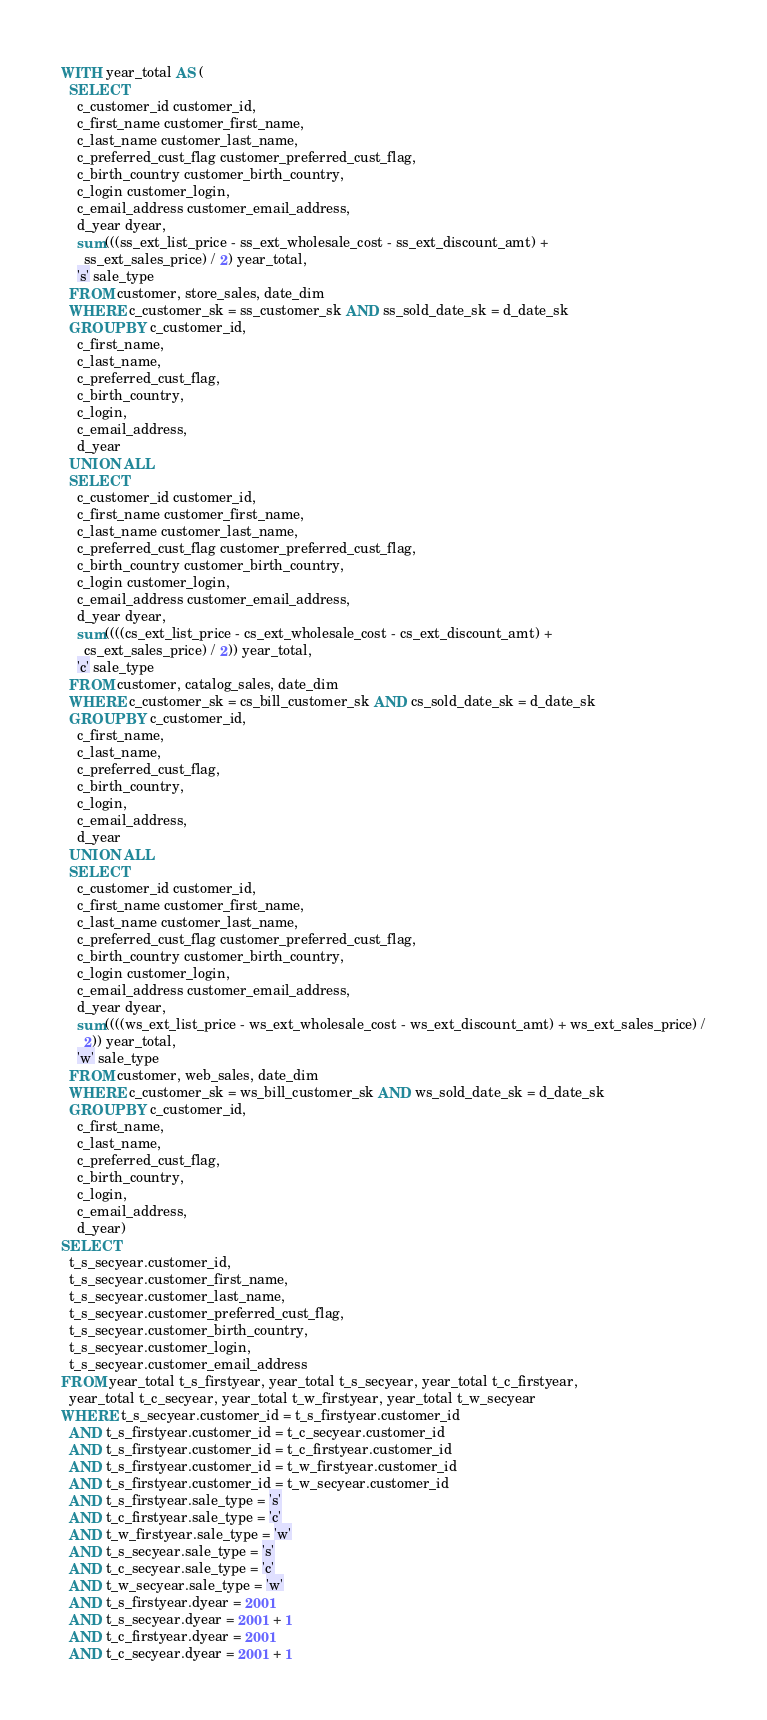<code> <loc_0><loc_0><loc_500><loc_500><_SQL_>WITH year_total AS (
  SELECT
    c_customer_id customer_id,
    c_first_name customer_first_name,
    c_last_name customer_last_name,
    c_preferred_cust_flag customer_preferred_cust_flag,
    c_birth_country customer_birth_country,
    c_login customer_login,
    c_email_address customer_email_address,
    d_year dyear,
    sum(((ss_ext_list_price - ss_ext_wholesale_cost - ss_ext_discount_amt) +
      ss_ext_sales_price) / 2) year_total,
    's' sale_type
  FROM customer, store_sales, date_dim
  WHERE c_customer_sk = ss_customer_sk AND ss_sold_date_sk = d_date_sk
  GROUP BY c_customer_id,
    c_first_name,
    c_last_name,
    c_preferred_cust_flag,
    c_birth_country,
    c_login,
    c_email_address,
    d_year
  UNION ALL
  SELECT
    c_customer_id customer_id,
    c_first_name customer_first_name,
    c_last_name customer_last_name,
    c_preferred_cust_flag customer_preferred_cust_flag,
    c_birth_country customer_birth_country,
    c_login customer_login,
    c_email_address customer_email_address,
    d_year dyear,
    sum((((cs_ext_list_price - cs_ext_wholesale_cost - cs_ext_discount_amt) +
      cs_ext_sales_price) / 2)) year_total,
    'c' sale_type
  FROM customer, catalog_sales, date_dim
  WHERE c_customer_sk = cs_bill_customer_sk AND cs_sold_date_sk = d_date_sk
  GROUP BY c_customer_id,
    c_first_name,
    c_last_name,
    c_preferred_cust_flag,
    c_birth_country,
    c_login,
    c_email_address,
    d_year
  UNION ALL
  SELECT
    c_customer_id customer_id,
    c_first_name customer_first_name,
    c_last_name customer_last_name,
    c_preferred_cust_flag customer_preferred_cust_flag,
    c_birth_country customer_birth_country,
    c_login customer_login,
    c_email_address customer_email_address,
    d_year dyear,
    sum((((ws_ext_list_price - ws_ext_wholesale_cost - ws_ext_discount_amt) + ws_ext_sales_price) /
      2)) year_total,
    'w' sale_type
  FROM customer, web_sales, date_dim
  WHERE c_customer_sk = ws_bill_customer_sk AND ws_sold_date_sk = d_date_sk
  GROUP BY c_customer_id,
    c_first_name,
    c_last_name,
    c_preferred_cust_flag,
    c_birth_country,
    c_login,
    c_email_address,
    d_year)
SELECT
  t_s_secyear.customer_id,
  t_s_secyear.customer_first_name,
  t_s_secyear.customer_last_name,
  t_s_secyear.customer_preferred_cust_flag,
  t_s_secyear.customer_birth_country,
  t_s_secyear.customer_login,
  t_s_secyear.customer_email_address
FROM year_total t_s_firstyear, year_total t_s_secyear, year_total t_c_firstyear,
  year_total t_c_secyear, year_total t_w_firstyear, year_total t_w_secyear
WHERE t_s_secyear.customer_id = t_s_firstyear.customer_id
  AND t_s_firstyear.customer_id = t_c_secyear.customer_id
  AND t_s_firstyear.customer_id = t_c_firstyear.customer_id
  AND t_s_firstyear.customer_id = t_w_firstyear.customer_id
  AND t_s_firstyear.customer_id = t_w_secyear.customer_id
  AND t_s_firstyear.sale_type = 's'
  AND t_c_firstyear.sale_type = 'c'
  AND t_w_firstyear.sale_type = 'w'
  AND t_s_secyear.sale_type = 's'
  AND t_c_secyear.sale_type = 'c'
  AND t_w_secyear.sale_type = 'w'
  AND t_s_firstyear.dyear = 2001
  AND t_s_secyear.dyear = 2001 + 1
  AND t_c_firstyear.dyear = 2001
  AND t_c_secyear.dyear = 2001 + 1</code> 